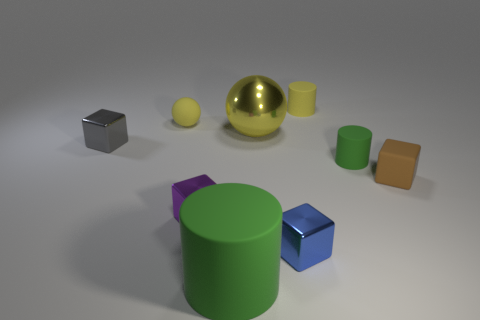There is a shiny thing behind the metal block behind the brown cube that is on the right side of the big yellow sphere; what shape is it?
Offer a terse response. Sphere. What is the material of the small gray thing that is the same shape as the blue shiny object?
Ensure brevity in your answer.  Metal. How many yellow rubber cylinders are there?
Ensure brevity in your answer.  1. What is the shape of the large object that is in front of the gray shiny cube?
Offer a terse response. Cylinder. There is a cylinder that is on the left side of the matte cylinder behind the small yellow matte object in front of the small yellow matte cylinder; what is its color?
Provide a succinct answer. Green. What shape is the tiny brown object that is made of the same material as the small green thing?
Offer a terse response. Cube. Are there fewer small blue shiny cubes than large objects?
Ensure brevity in your answer.  Yes. Is the tiny green cylinder made of the same material as the tiny yellow cylinder?
Keep it short and to the point. Yes. How many other things are there of the same color as the large sphere?
Give a very brief answer. 2. Is the number of big yellow objects greater than the number of tiny yellow rubber things?
Ensure brevity in your answer.  No. 